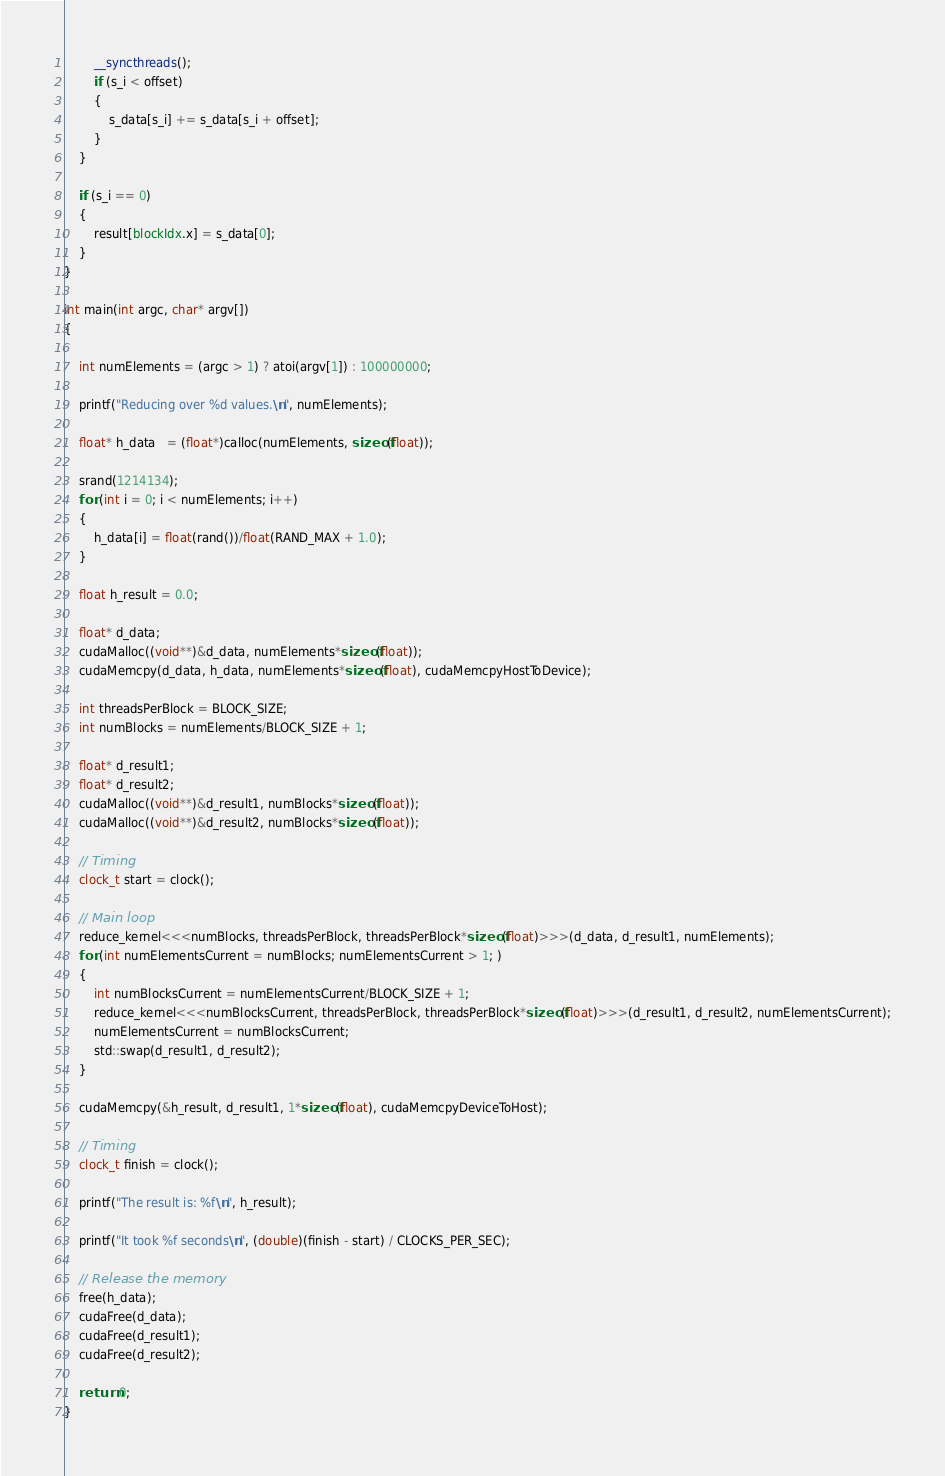Convert code to text. <code><loc_0><loc_0><loc_500><loc_500><_Cuda_>        __syncthreads();
        if (s_i < offset)
        {
            s_data[s_i] += s_data[s_i + offset];
        }
    }

    if (s_i == 0)
    {
        result[blockIdx.x] = s_data[0];
    }
}

int main(int argc, char* argv[])
{

    int numElements = (argc > 1) ? atoi(argv[1]) : 100000000;

    printf("Reducing over %d values.\n", numElements);

    float* h_data   = (float*)calloc(numElements, sizeof(float));

    srand(1214134);
    for (int i = 0; i < numElements; i++)
    {
        h_data[i] = float(rand())/float(RAND_MAX + 1.0);
    }

    float h_result = 0.0;

    float* d_data;
    cudaMalloc((void**)&d_data, numElements*sizeof(float));
    cudaMemcpy(d_data, h_data, numElements*sizeof(float), cudaMemcpyHostToDevice);

    int threadsPerBlock = BLOCK_SIZE;
    int numBlocks = numElements/BLOCK_SIZE + 1;

    float* d_result1;
    float* d_result2;
    cudaMalloc((void**)&d_result1, numBlocks*sizeof(float));
    cudaMalloc((void**)&d_result2, numBlocks*sizeof(float));

    // Timing
    clock_t start = clock();

    // Main loop
    reduce_kernel<<<numBlocks, threadsPerBlock, threadsPerBlock*sizeof(float)>>>(d_data, d_result1, numElements);
    for (int numElementsCurrent = numBlocks; numElementsCurrent > 1; )
    {
        int numBlocksCurrent = numElementsCurrent/BLOCK_SIZE + 1;
        reduce_kernel<<<numBlocksCurrent, threadsPerBlock, threadsPerBlock*sizeof(float)>>>(d_result1, d_result2, numElementsCurrent);
        numElementsCurrent = numBlocksCurrent;
        std::swap(d_result1, d_result2);
    }

    cudaMemcpy(&h_result, d_result1, 1*sizeof(float), cudaMemcpyDeviceToHost);

    // Timing
    clock_t finish = clock();

    printf("The result is: %f\n", h_result);

    printf("It took %f seconds\n", (double)(finish - start) / CLOCKS_PER_SEC);

    // Release the memory
    free(h_data);
    cudaFree(d_data);
    cudaFree(d_result1);
    cudaFree(d_result2);
    
    return 0;
}</code> 